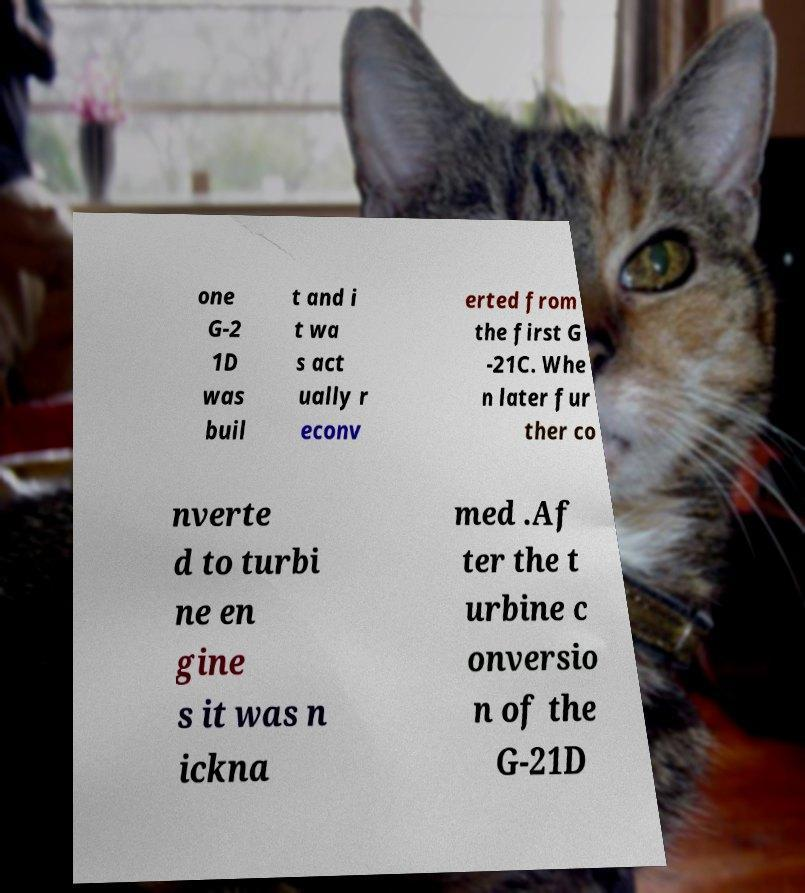There's text embedded in this image that I need extracted. Can you transcribe it verbatim? one G-2 1D was buil t and i t wa s act ually r econv erted from the first G -21C. Whe n later fur ther co nverte d to turbi ne en gine s it was n ickna med .Af ter the t urbine c onversio n of the G-21D 